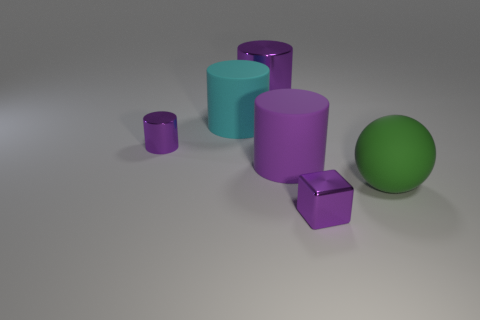Subtract all purple cylinders. How many were subtracted if there are1purple cylinders left? 2 Add 2 small purple shiny things. How many objects exist? 8 Subtract all cyan cylinders. How many cylinders are left? 3 Subtract all cyan cylinders. How many cylinders are left? 3 Subtract 1 green spheres. How many objects are left? 5 Subtract all cubes. How many objects are left? 5 Subtract 1 cubes. How many cubes are left? 0 Subtract all gray cylinders. Subtract all yellow spheres. How many cylinders are left? 4 Subtract all brown cylinders. How many red cubes are left? 0 Subtract all small purple metallic balls. Subtract all rubber cylinders. How many objects are left? 4 